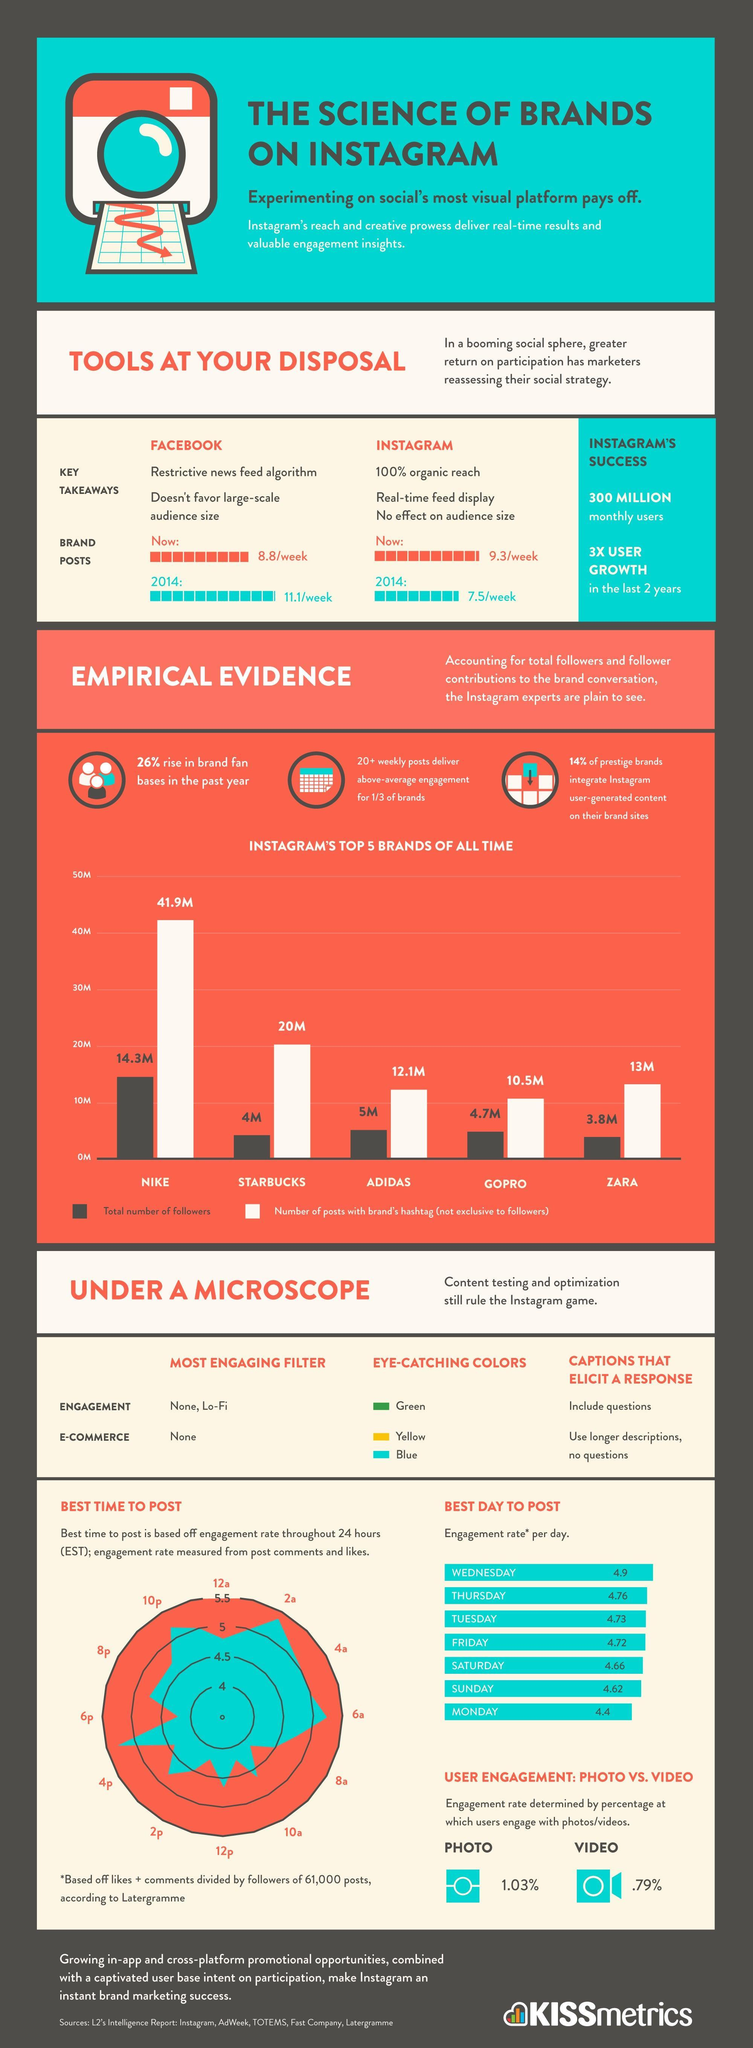What are the eye-catching colors?
Answer the question with a short phrase. Green, Yellow, Blue Which is the best day to post? Wednesday 